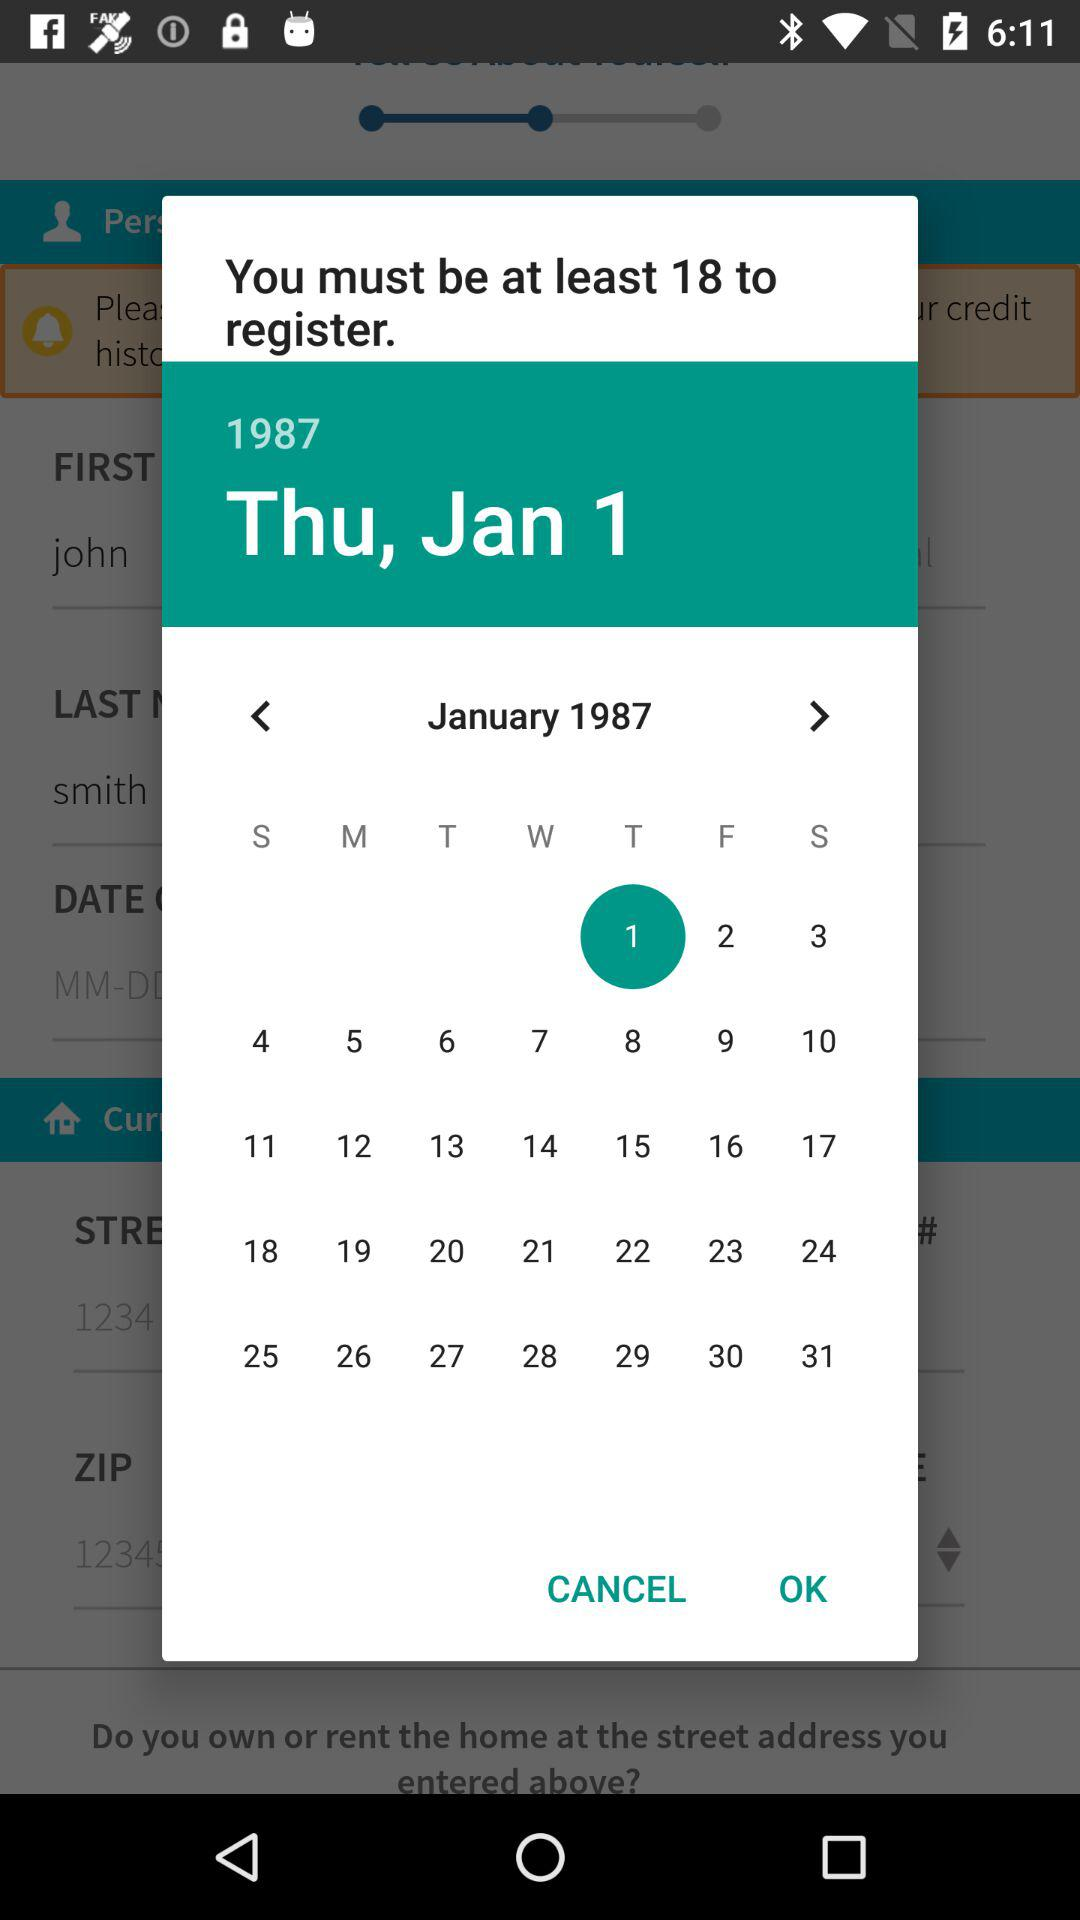What's the selected date? The selected date is Thursday, January 1, 1987. 